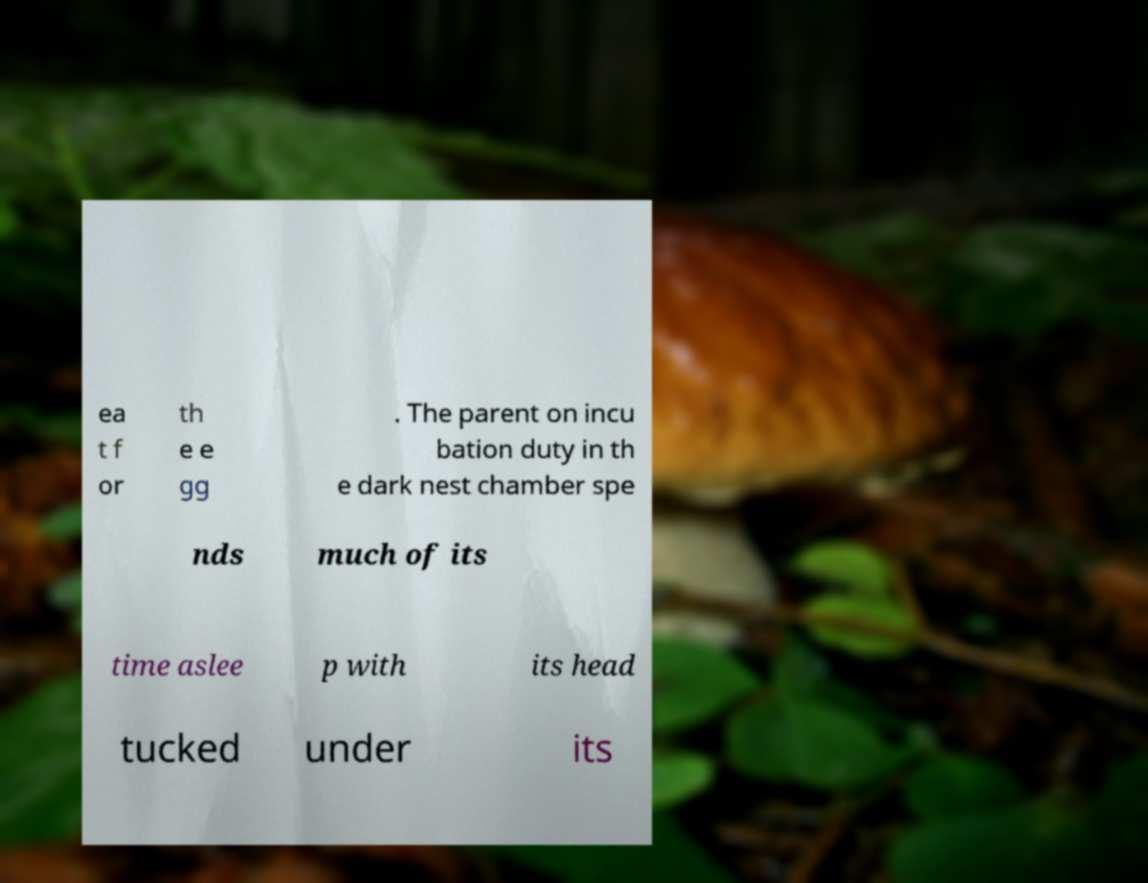I need the written content from this picture converted into text. Can you do that? ea t f or th e e gg . The parent on incu bation duty in th e dark nest chamber spe nds much of its time aslee p with its head tucked under its 